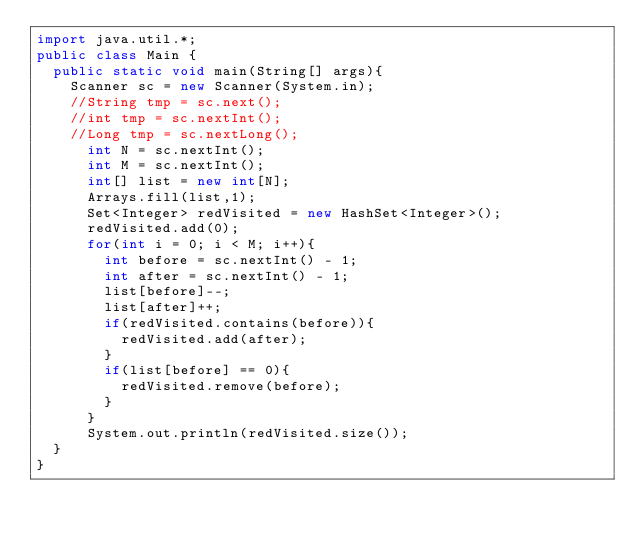<code> <loc_0><loc_0><loc_500><loc_500><_Java_>import java.util.*;
public class Main {
	public static void main(String[] args){
		Scanner sc = new Scanner(System.in);
		//String tmp = sc.next();
		//int tmp = sc.nextInt();
		//Long tmp = sc.nextLong();
      int N = sc.nextInt();
      int M = sc.nextInt();
      int[] list = new int[N];
      Arrays.fill(list,1);
      Set<Integer> redVisited = new HashSet<Integer>();
      redVisited.add(0);
      for(int i = 0; i < M; i++){
        int before = sc.nextInt() - 1;
        int after = sc.nextInt() - 1;
        list[before]--;
        list[after]++;
        if(redVisited.contains(before)){
          redVisited.add(after);
        }
        if(list[before] == 0){
          redVisited.remove(before);
        }
      }
      System.out.println(redVisited.size());
	}
}
</code> 